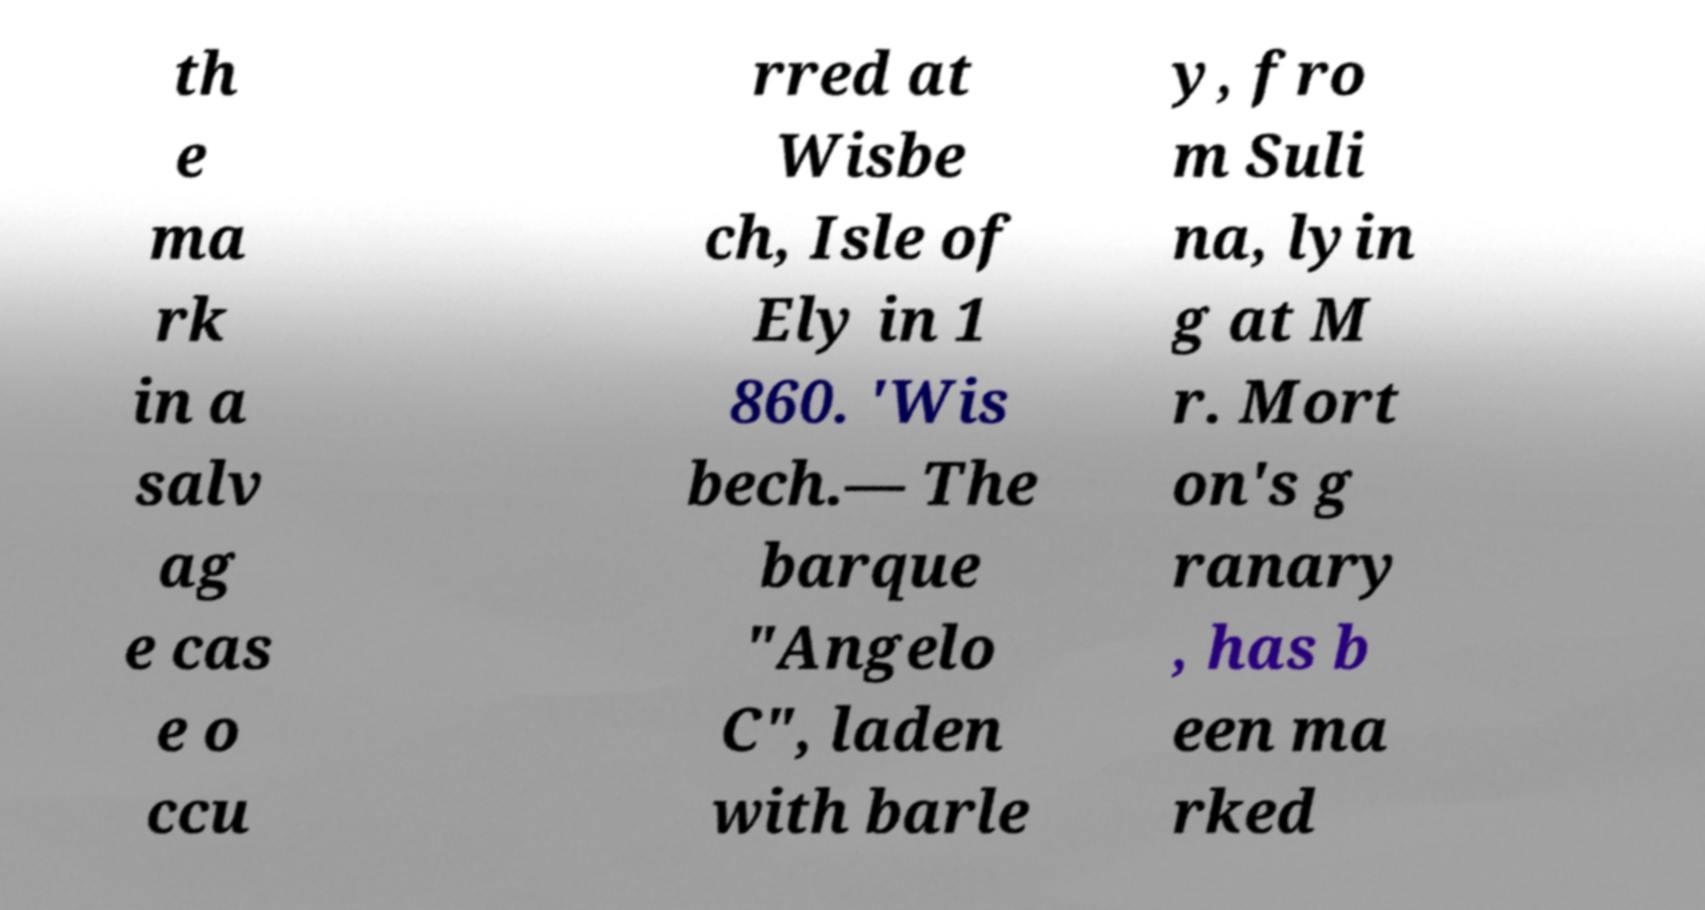Can you read and provide the text displayed in the image?This photo seems to have some interesting text. Can you extract and type it out for me? th e ma rk in a salv ag e cas e o ccu rred at Wisbe ch, Isle of Ely in 1 860. 'Wis bech.— The barque "Angelo C", laden with barle y, fro m Suli na, lyin g at M r. Mort on's g ranary , has b een ma rked 